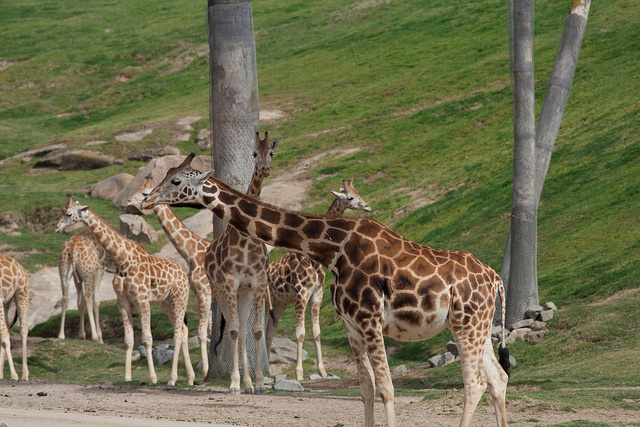Describe the objects in this image and their specific colors. I can see giraffe in darkgreen, black, gray, and maroon tones, giraffe in darkgreen, gray, and tan tones, giraffe in darkgreen, gray, and maroon tones, giraffe in darkgreen, gray, maroon, and darkgray tones, and giraffe in darkgreen, gray, tan, and darkgray tones in this image. 